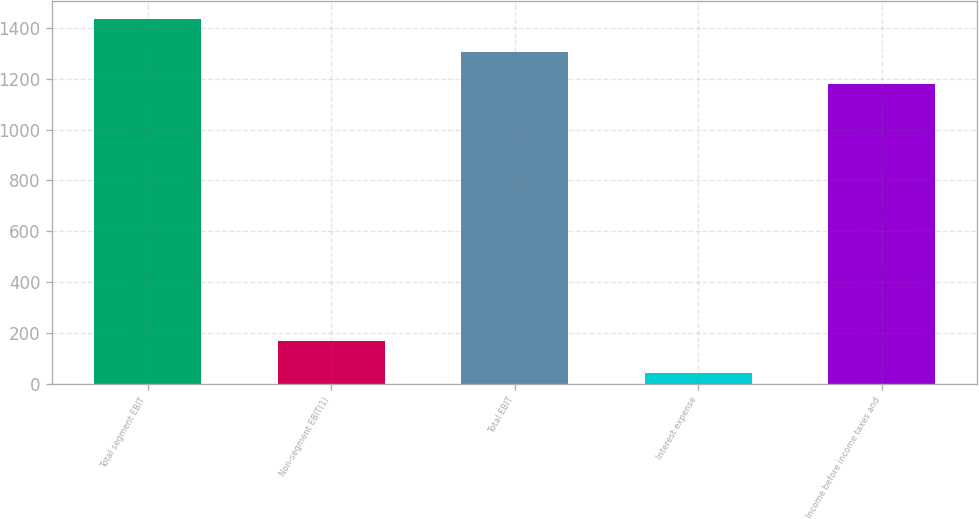Convert chart to OTSL. <chart><loc_0><loc_0><loc_500><loc_500><bar_chart><fcel>Total segment EBIT<fcel>Non-segment EBIT(1)<fcel>Total EBIT<fcel>Interest expense<fcel>Income before income taxes and<nl><fcel>1434<fcel>170<fcel>1306<fcel>42<fcel>1178<nl></chart> 